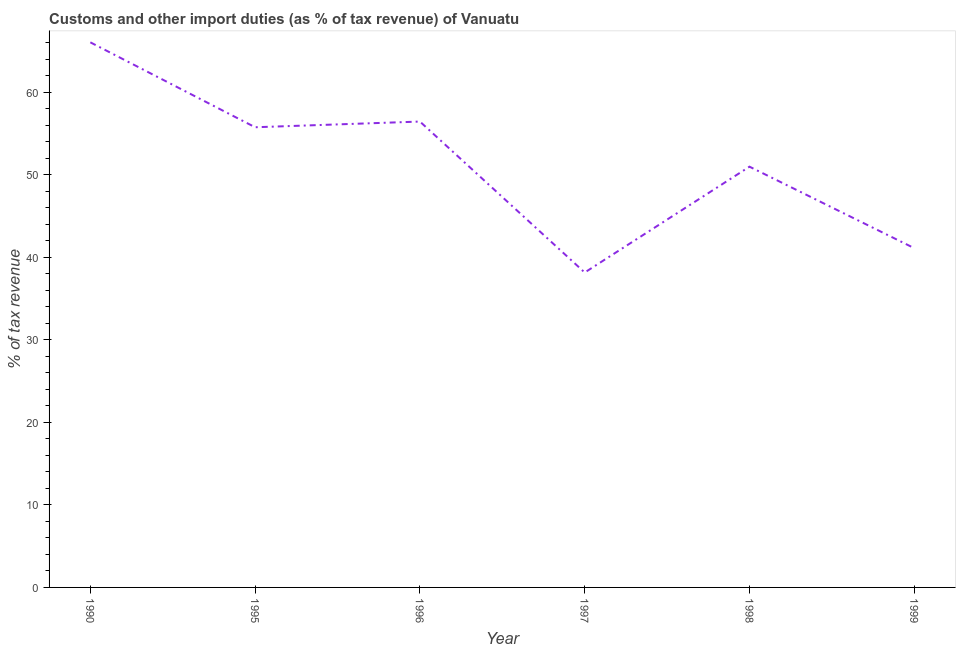What is the customs and other import duties in 1990?
Offer a very short reply. 66.02. Across all years, what is the maximum customs and other import duties?
Give a very brief answer. 66.02. Across all years, what is the minimum customs and other import duties?
Ensure brevity in your answer.  38.14. What is the sum of the customs and other import duties?
Provide a short and direct response. 308.37. What is the difference between the customs and other import duties in 1990 and 1998?
Ensure brevity in your answer.  15.06. What is the average customs and other import duties per year?
Your response must be concise. 51.4. What is the median customs and other import duties?
Your answer should be compact. 53.35. What is the ratio of the customs and other import duties in 1990 to that in 1995?
Your answer should be compact. 1.18. Is the customs and other import duties in 1990 less than that in 1995?
Make the answer very short. No. Is the difference between the customs and other import duties in 1990 and 1997 greater than the difference between any two years?
Your answer should be compact. Yes. What is the difference between the highest and the second highest customs and other import duties?
Make the answer very short. 9.59. Is the sum of the customs and other import duties in 1990 and 1996 greater than the maximum customs and other import duties across all years?
Provide a short and direct response. Yes. What is the difference between the highest and the lowest customs and other import duties?
Provide a short and direct response. 27.88. Are the values on the major ticks of Y-axis written in scientific E-notation?
Give a very brief answer. No. Does the graph contain grids?
Make the answer very short. No. What is the title of the graph?
Your answer should be compact. Customs and other import duties (as % of tax revenue) of Vanuatu. What is the label or title of the X-axis?
Keep it short and to the point. Year. What is the label or title of the Y-axis?
Make the answer very short. % of tax revenue. What is the % of tax revenue in 1990?
Offer a terse response. 66.02. What is the % of tax revenue in 1995?
Make the answer very short. 55.74. What is the % of tax revenue of 1996?
Provide a short and direct response. 56.43. What is the % of tax revenue of 1997?
Your answer should be very brief. 38.14. What is the % of tax revenue in 1998?
Keep it short and to the point. 50.96. What is the % of tax revenue of 1999?
Provide a succinct answer. 41.09. What is the difference between the % of tax revenue in 1990 and 1995?
Give a very brief answer. 10.29. What is the difference between the % of tax revenue in 1990 and 1996?
Make the answer very short. 9.59. What is the difference between the % of tax revenue in 1990 and 1997?
Offer a terse response. 27.88. What is the difference between the % of tax revenue in 1990 and 1998?
Your answer should be very brief. 15.06. What is the difference between the % of tax revenue in 1990 and 1999?
Offer a terse response. 24.93. What is the difference between the % of tax revenue in 1995 and 1996?
Your response must be concise. -0.69. What is the difference between the % of tax revenue in 1995 and 1997?
Your answer should be very brief. 17.59. What is the difference between the % of tax revenue in 1995 and 1998?
Provide a succinct answer. 4.77. What is the difference between the % of tax revenue in 1995 and 1999?
Provide a succinct answer. 14.65. What is the difference between the % of tax revenue in 1996 and 1997?
Your answer should be compact. 18.28. What is the difference between the % of tax revenue in 1996 and 1998?
Ensure brevity in your answer.  5.47. What is the difference between the % of tax revenue in 1996 and 1999?
Provide a short and direct response. 15.34. What is the difference between the % of tax revenue in 1997 and 1998?
Give a very brief answer. -12.82. What is the difference between the % of tax revenue in 1997 and 1999?
Offer a terse response. -2.94. What is the difference between the % of tax revenue in 1998 and 1999?
Make the answer very short. 9.87. What is the ratio of the % of tax revenue in 1990 to that in 1995?
Offer a very short reply. 1.19. What is the ratio of the % of tax revenue in 1990 to that in 1996?
Your answer should be compact. 1.17. What is the ratio of the % of tax revenue in 1990 to that in 1997?
Your answer should be compact. 1.73. What is the ratio of the % of tax revenue in 1990 to that in 1998?
Your answer should be compact. 1.3. What is the ratio of the % of tax revenue in 1990 to that in 1999?
Make the answer very short. 1.61. What is the ratio of the % of tax revenue in 1995 to that in 1997?
Your answer should be compact. 1.46. What is the ratio of the % of tax revenue in 1995 to that in 1998?
Make the answer very short. 1.09. What is the ratio of the % of tax revenue in 1995 to that in 1999?
Make the answer very short. 1.36. What is the ratio of the % of tax revenue in 1996 to that in 1997?
Your answer should be compact. 1.48. What is the ratio of the % of tax revenue in 1996 to that in 1998?
Your answer should be very brief. 1.11. What is the ratio of the % of tax revenue in 1996 to that in 1999?
Ensure brevity in your answer.  1.37. What is the ratio of the % of tax revenue in 1997 to that in 1998?
Offer a very short reply. 0.75. What is the ratio of the % of tax revenue in 1997 to that in 1999?
Your answer should be very brief. 0.93. What is the ratio of the % of tax revenue in 1998 to that in 1999?
Provide a succinct answer. 1.24. 